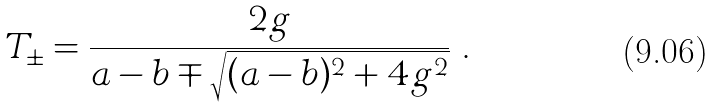Convert formula to latex. <formula><loc_0><loc_0><loc_500><loc_500>T _ { \pm } = \frac { 2 g } { a - b \mp \sqrt { ( a - b ) ^ { 2 } + 4 g ^ { 2 } } } \ .</formula> 